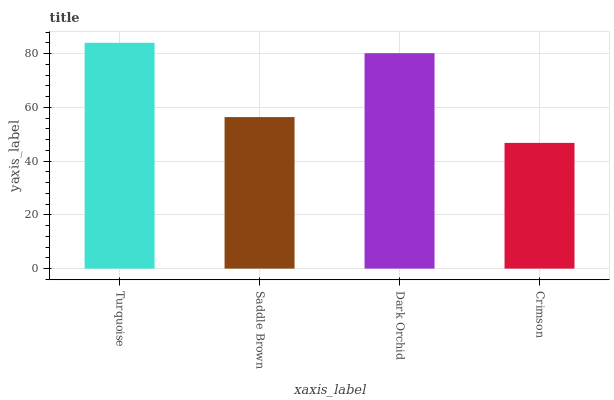Is Crimson the minimum?
Answer yes or no. Yes. Is Turquoise the maximum?
Answer yes or no. Yes. Is Saddle Brown the minimum?
Answer yes or no. No. Is Saddle Brown the maximum?
Answer yes or no. No. Is Turquoise greater than Saddle Brown?
Answer yes or no. Yes. Is Saddle Brown less than Turquoise?
Answer yes or no. Yes. Is Saddle Brown greater than Turquoise?
Answer yes or no. No. Is Turquoise less than Saddle Brown?
Answer yes or no. No. Is Dark Orchid the high median?
Answer yes or no. Yes. Is Saddle Brown the low median?
Answer yes or no. Yes. Is Turquoise the high median?
Answer yes or no. No. Is Turquoise the low median?
Answer yes or no. No. 